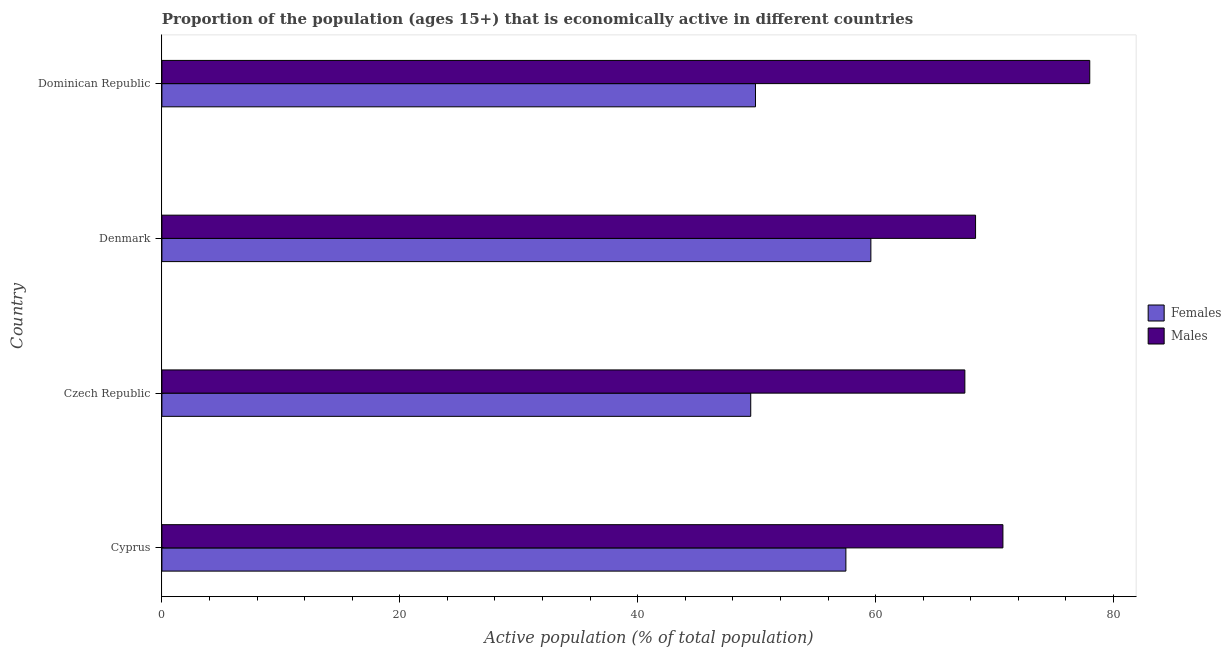Are the number of bars per tick equal to the number of legend labels?
Offer a very short reply. Yes. How many bars are there on the 2nd tick from the top?
Your answer should be very brief. 2. What is the label of the 2nd group of bars from the top?
Offer a very short reply. Denmark. What is the percentage of economically active male population in Czech Republic?
Keep it short and to the point. 67.5. Across all countries, what is the maximum percentage of economically active female population?
Offer a terse response. 59.6. Across all countries, what is the minimum percentage of economically active male population?
Give a very brief answer. 67.5. In which country was the percentage of economically active male population maximum?
Ensure brevity in your answer.  Dominican Republic. In which country was the percentage of economically active male population minimum?
Ensure brevity in your answer.  Czech Republic. What is the total percentage of economically active male population in the graph?
Offer a terse response. 284.6. What is the difference between the percentage of economically active male population in Cyprus and the percentage of economically active female population in Denmark?
Make the answer very short. 11.1. What is the average percentage of economically active male population per country?
Your response must be concise. 71.15. What is the difference between the percentage of economically active male population and percentage of economically active female population in Cyprus?
Offer a very short reply. 13.2. In how many countries, is the percentage of economically active female population greater than 52 %?
Your response must be concise. 2. What is the ratio of the percentage of economically active male population in Cyprus to that in Dominican Republic?
Ensure brevity in your answer.  0.91. Is the percentage of economically active female population in Cyprus less than that in Denmark?
Your answer should be compact. Yes. Is the difference between the percentage of economically active female population in Denmark and Dominican Republic greater than the difference between the percentage of economically active male population in Denmark and Dominican Republic?
Offer a terse response. Yes. What is the difference between the highest and the lowest percentage of economically active male population?
Your response must be concise. 10.5. What does the 1st bar from the top in Cyprus represents?
Offer a very short reply. Males. What does the 1st bar from the bottom in Cyprus represents?
Provide a short and direct response. Females. How many bars are there?
Give a very brief answer. 8. Are all the bars in the graph horizontal?
Offer a very short reply. Yes. How many countries are there in the graph?
Make the answer very short. 4. Are the values on the major ticks of X-axis written in scientific E-notation?
Your answer should be very brief. No. Does the graph contain any zero values?
Ensure brevity in your answer.  No. Does the graph contain grids?
Provide a succinct answer. No. How are the legend labels stacked?
Provide a succinct answer. Vertical. What is the title of the graph?
Your response must be concise. Proportion of the population (ages 15+) that is economically active in different countries. What is the label or title of the X-axis?
Your answer should be very brief. Active population (% of total population). What is the label or title of the Y-axis?
Give a very brief answer. Country. What is the Active population (% of total population) of Females in Cyprus?
Your response must be concise. 57.5. What is the Active population (% of total population) of Males in Cyprus?
Your answer should be very brief. 70.7. What is the Active population (% of total population) of Females in Czech Republic?
Keep it short and to the point. 49.5. What is the Active population (% of total population) of Males in Czech Republic?
Offer a terse response. 67.5. What is the Active population (% of total population) in Females in Denmark?
Make the answer very short. 59.6. What is the Active population (% of total population) in Males in Denmark?
Keep it short and to the point. 68.4. What is the Active population (% of total population) of Females in Dominican Republic?
Your answer should be compact. 49.9. What is the Active population (% of total population) of Males in Dominican Republic?
Keep it short and to the point. 78. Across all countries, what is the maximum Active population (% of total population) of Females?
Make the answer very short. 59.6. Across all countries, what is the maximum Active population (% of total population) of Males?
Your answer should be very brief. 78. Across all countries, what is the minimum Active population (% of total population) in Females?
Your response must be concise. 49.5. Across all countries, what is the minimum Active population (% of total population) of Males?
Provide a short and direct response. 67.5. What is the total Active population (% of total population) of Females in the graph?
Your response must be concise. 216.5. What is the total Active population (% of total population) in Males in the graph?
Ensure brevity in your answer.  284.6. What is the difference between the Active population (% of total population) of Females in Cyprus and that in Dominican Republic?
Ensure brevity in your answer.  7.6. What is the difference between the Active population (% of total population) of Males in Cyprus and that in Dominican Republic?
Keep it short and to the point. -7.3. What is the difference between the Active population (% of total population) in Females in Czech Republic and that in Dominican Republic?
Your answer should be very brief. -0.4. What is the difference between the Active population (% of total population) in Males in Denmark and that in Dominican Republic?
Your response must be concise. -9.6. What is the difference between the Active population (% of total population) of Females in Cyprus and the Active population (% of total population) of Males in Denmark?
Your answer should be very brief. -10.9. What is the difference between the Active population (% of total population) in Females in Cyprus and the Active population (% of total population) in Males in Dominican Republic?
Give a very brief answer. -20.5. What is the difference between the Active population (% of total population) in Females in Czech Republic and the Active population (% of total population) in Males in Denmark?
Keep it short and to the point. -18.9. What is the difference between the Active population (% of total population) in Females in Czech Republic and the Active population (% of total population) in Males in Dominican Republic?
Provide a short and direct response. -28.5. What is the difference between the Active population (% of total population) of Females in Denmark and the Active population (% of total population) of Males in Dominican Republic?
Keep it short and to the point. -18.4. What is the average Active population (% of total population) in Females per country?
Offer a terse response. 54.12. What is the average Active population (% of total population) of Males per country?
Your answer should be compact. 71.15. What is the difference between the Active population (% of total population) in Females and Active population (% of total population) in Males in Cyprus?
Your answer should be compact. -13.2. What is the difference between the Active population (% of total population) of Females and Active population (% of total population) of Males in Czech Republic?
Your response must be concise. -18. What is the difference between the Active population (% of total population) of Females and Active population (% of total population) of Males in Denmark?
Give a very brief answer. -8.8. What is the difference between the Active population (% of total population) in Females and Active population (% of total population) in Males in Dominican Republic?
Provide a succinct answer. -28.1. What is the ratio of the Active population (% of total population) of Females in Cyprus to that in Czech Republic?
Offer a terse response. 1.16. What is the ratio of the Active population (% of total population) in Males in Cyprus to that in Czech Republic?
Make the answer very short. 1.05. What is the ratio of the Active population (% of total population) in Females in Cyprus to that in Denmark?
Give a very brief answer. 0.96. What is the ratio of the Active population (% of total population) of Males in Cyprus to that in Denmark?
Provide a short and direct response. 1.03. What is the ratio of the Active population (% of total population) of Females in Cyprus to that in Dominican Republic?
Provide a succinct answer. 1.15. What is the ratio of the Active population (% of total population) in Males in Cyprus to that in Dominican Republic?
Make the answer very short. 0.91. What is the ratio of the Active population (% of total population) in Females in Czech Republic to that in Denmark?
Provide a succinct answer. 0.83. What is the ratio of the Active population (% of total population) of Females in Czech Republic to that in Dominican Republic?
Your response must be concise. 0.99. What is the ratio of the Active population (% of total population) in Males in Czech Republic to that in Dominican Republic?
Offer a terse response. 0.87. What is the ratio of the Active population (% of total population) of Females in Denmark to that in Dominican Republic?
Make the answer very short. 1.19. What is the ratio of the Active population (% of total population) in Males in Denmark to that in Dominican Republic?
Your answer should be very brief. 0.88. What is the difference between the highest and the second highest Active population (% of total population) of Females?
Ensure brevity in your answer.  2.1. What is the difference between the highest and the second highest Active population (% of total population) in Males?
Ensure brevity in your answer.  7.3. What is the difference between the highest and the lowest Active population (% of total population) in Females?
Ensure brevity in your answer.  10.1. 